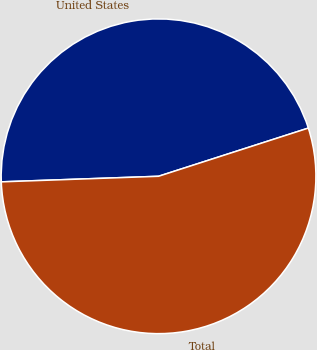<chart> <loc_0><loc_0><loc_500><loc_500><pie_chart><fcel>United States<fcel>Total<nl><fcel>45.61%<fcel>54.39%<nl></chart> 